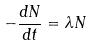<formula> <loc_0><loc_0><loc_500><loc_500>- \frac { d N } { d t } = \lambda N</formula> 